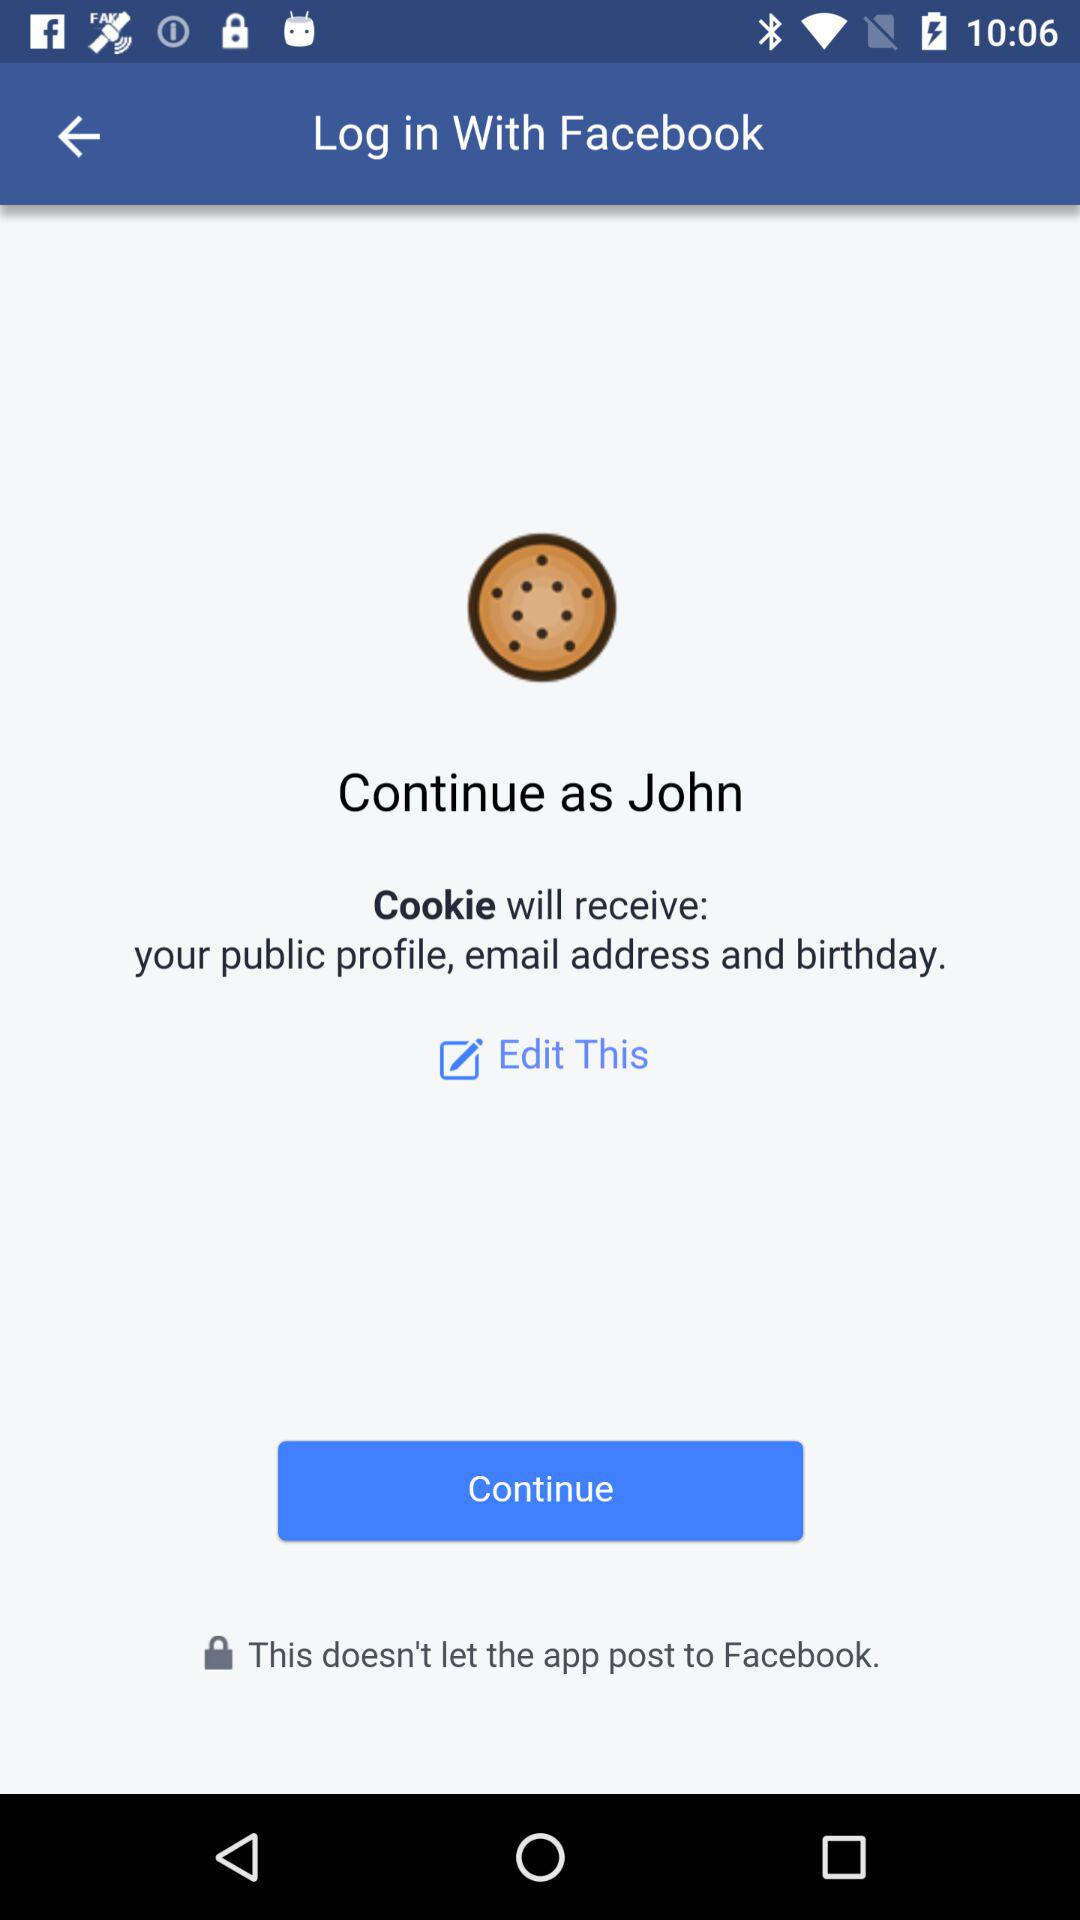Who will receive the public profile and email address? The application "Cookie" will receive the public profile and email address. 